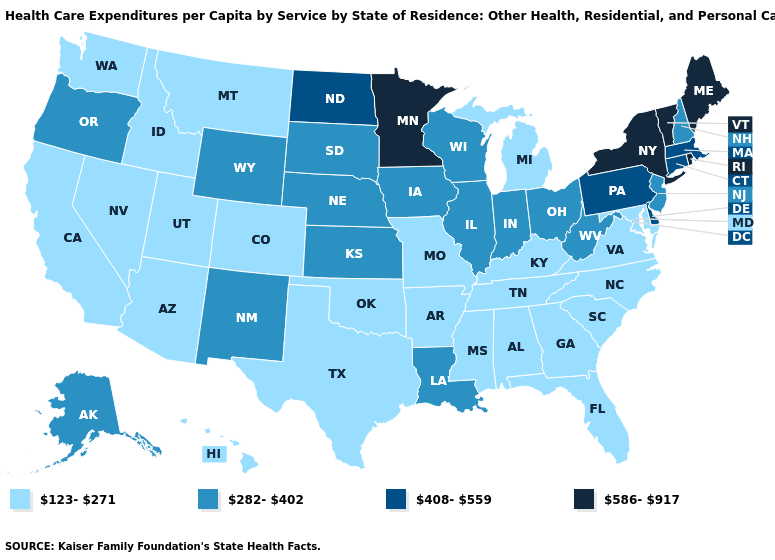Does Florida have the highest value in the USA?
Short answer required. No. Name the states that have a value in the range 586-917?
Keep it brief. Maine, Minnesota, New York, Rhode Island, Vermont. Among the states that border West Virginia , does Kentucky have the highest value?
Short answer required. No. What is the lowest value in the Northeast?
Give a very brief answer. 282-402. Does the first symbol in the legend represent the smallest category?
Answer briefly. Yes. Name the states that have a value in the range 282-402?
Quick response, please. Alaska, Illinois, Indiana, Iowa, Kansas, Louisiana, Nebraska, New Hampshire, New Jersey, New Mexico, Ohio, Oregon, South Dakota, West Virginia, Wisconsin, Wyoming. Name the states that have a value in the range 408-559?
Write a very short answer. Connecticut, Delaware, Massachusetts, North Dakota, Pennsylvania. What is the lowest value in the Northeast?
Be succinct. 282-402. Among the states that border Nevada , does Oregon have the lowest value?
Answer briefly. No. Name the states that have a value in the range 282-402?
Give a very brief answer. Alaska, Illinois, Indiana, Iowa, Kansas, Louisiana, Nebraska, New Hampshire, New Jersey, New Mexico, Ohio, Oregon, South Dakota, West Virginia, Wisconsin, Wyoming. Does Vermont have the highest value in the Northeast?
Concise answer only. Yes. What is the value of Nevada?
Give a very brief answer. 123-271. Does New Jersey have the highest value in the Northeast?
Quick response, please. No. Name the states that have a value in the range 586-917?
Answer briefly. Maine, Minnesota, New York, Rhode Island, Vermont. 